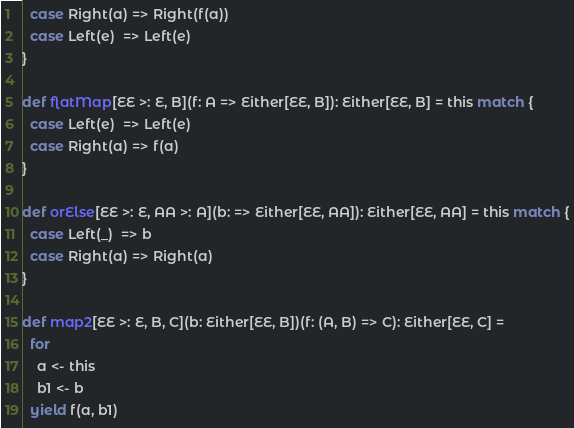<code> <loc_0><loc_0><loc_500><loc_500><_Scala_>  case Right(a) => Right(f(a))
  case Left(e)  => Left(e)
}

def flatMap[EE >: E, B](f: A => Either[EE, B]): Either[EE, B] = this match {
  case Left(e)  => Left(e)
  case Right(a) => f(a)
}

def orElse[EE >: E, AA >: A](b: => Either[EE, AA]): Either[EE, AA] = this match {
  case Left(_)  => b
  case Right(a) => Right(a)
}

def map2[EE >: E, B, C](b: Either[EE, B])(f: (A, B) => C): Either[EE, C] =
  for
    a <- this
    b1 <- b
  yield f(a, b1)
</code> 